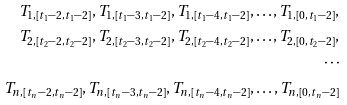<formula> <loc_0><loc_0><loc_500><loc_500>T _ { 1 , [ t _ { 1 } - 2 , t _ { 1 } - 2 ] } , T _ { 1 , [ t _ { 1 } - 3 , t _ { 1 } - 2 ] } , T _ { 1 , [ t _ { 1 } - 4 , t _ { 1 } - 2 ] } , \dots , T _ { 1 , [ 0 , t _ { 1 } - 2 ] } , \\ T _ { 2 , [ t _ { 2 } - 2 , t _ { 2 } - 2 ] } , T _ { 2 , [ t _ { 2 } - 3 , t _ { 2 } - 2 ] } , T _ { 2 , [ t _ { 2 } - 4 , t _ { 2 } - 2 ] } , \dots , T _ { 2 , [ 0 , t _ { 2 } - 2 ] } , \\ \cdots \\ T _ { n , [ t _ { n } - 2 , t _ { n } - 2 ] } , T _ { n , [ t _ { n } - 3 , t _ { n } - 2 ] } , T _ { n , [ t _ { n } - 4 , t _ { n } - 2 ] } , \dots , T _ { n , [ 0 , t _ { n } - 2 ] }</formula> 